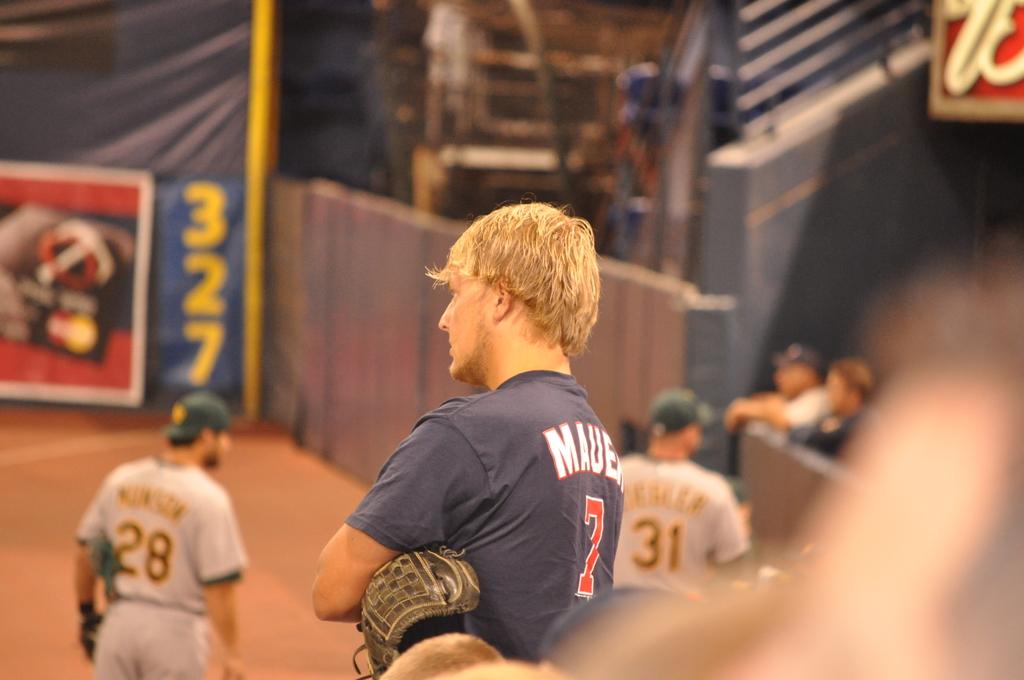What is the number on the blue jersey?
Provide a short and direct response. 7. 